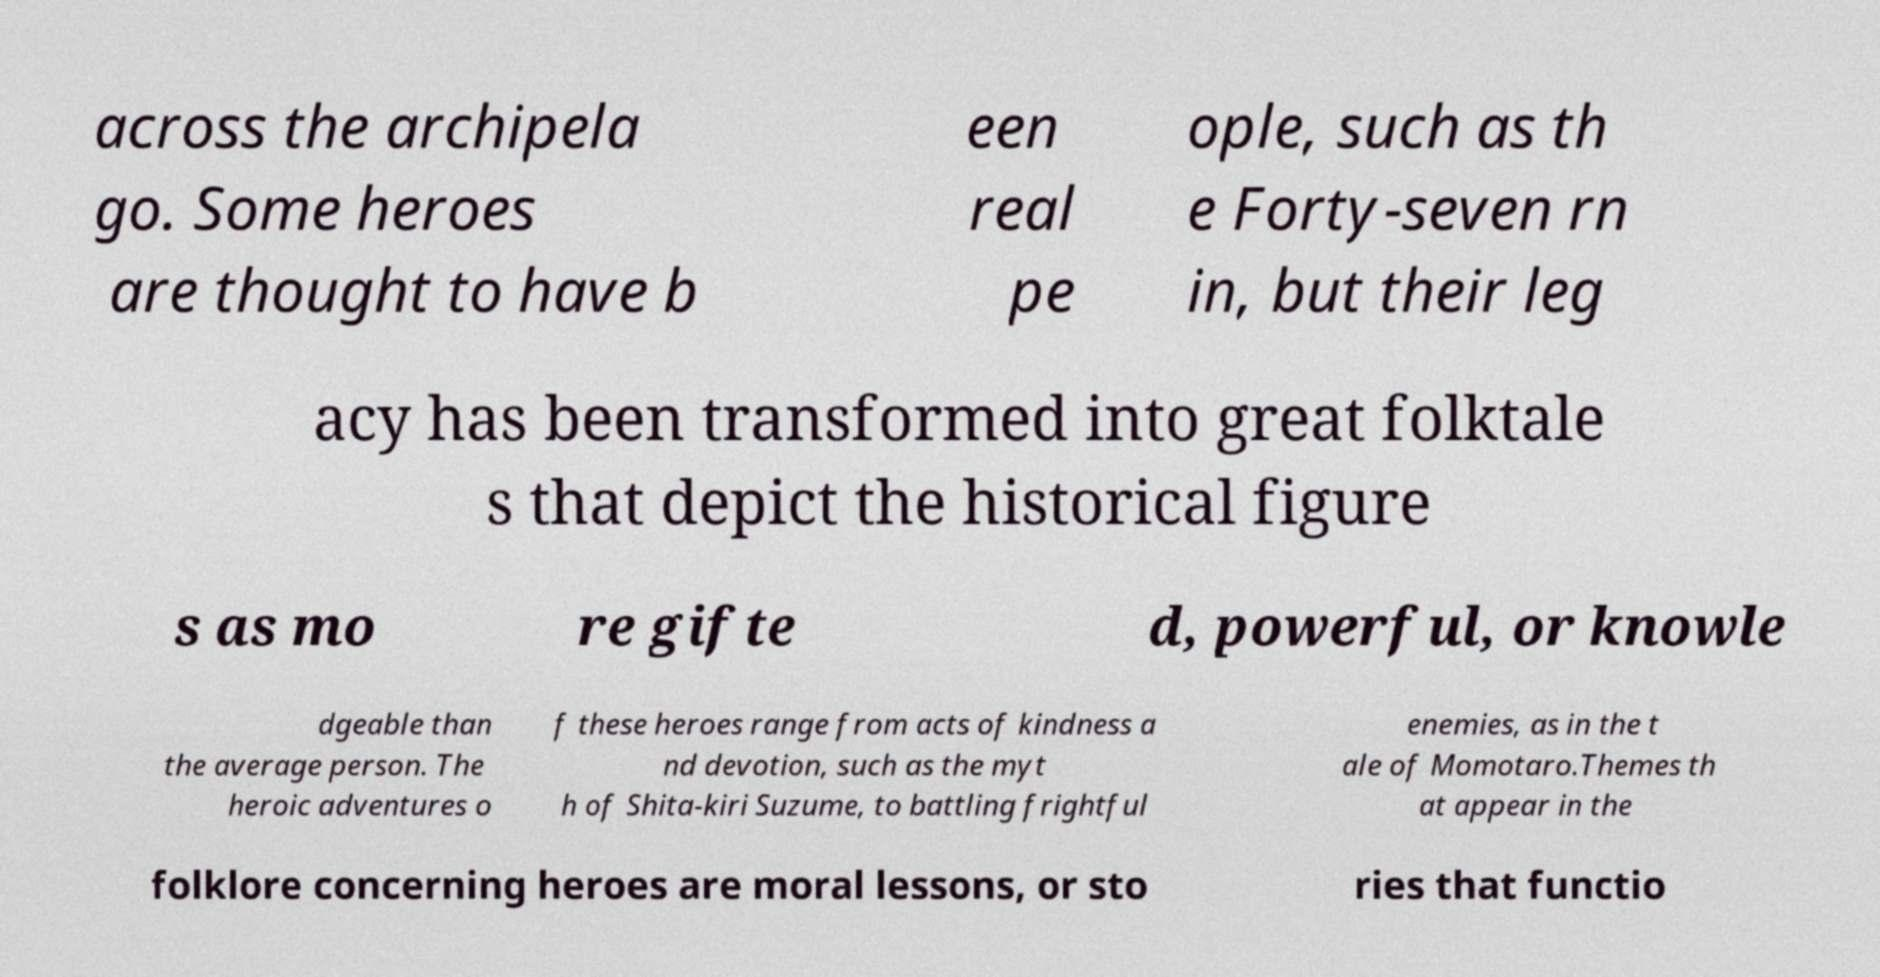What messages or text are displayed in this image? I need them in a readable, typed format. across the archipela go. Some heroes are thought to have b een real pe ople, such as th e Forty-seven rn in, but their leg acy has been transformed into great folktale s that depict the historical figure s as mo re gifte d, powerful, or knowle dgeable than the average person. The heroic adventures o f these heroes range from acts of kindness a nd devotion, such as the myt h of Shita-kiri Suzume, to battling frightful enemies, as in the t ale of Momotaro.Themes th at appear in the folklore concerning heroes are moral lessons, or sto ries that functio 